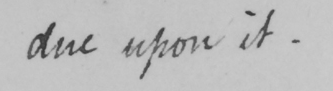Transcribe the text shown in this historical manuscript line. due upon it . 